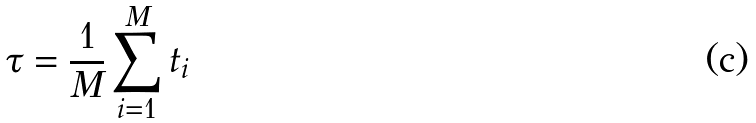Convert formula to latex. <formula><loc_0><loc_0><loc_500><loc_500>\tau = \frac { 1 } { M } \sum _ { i = 1 } ^ { M } t _ { i }</formula> 